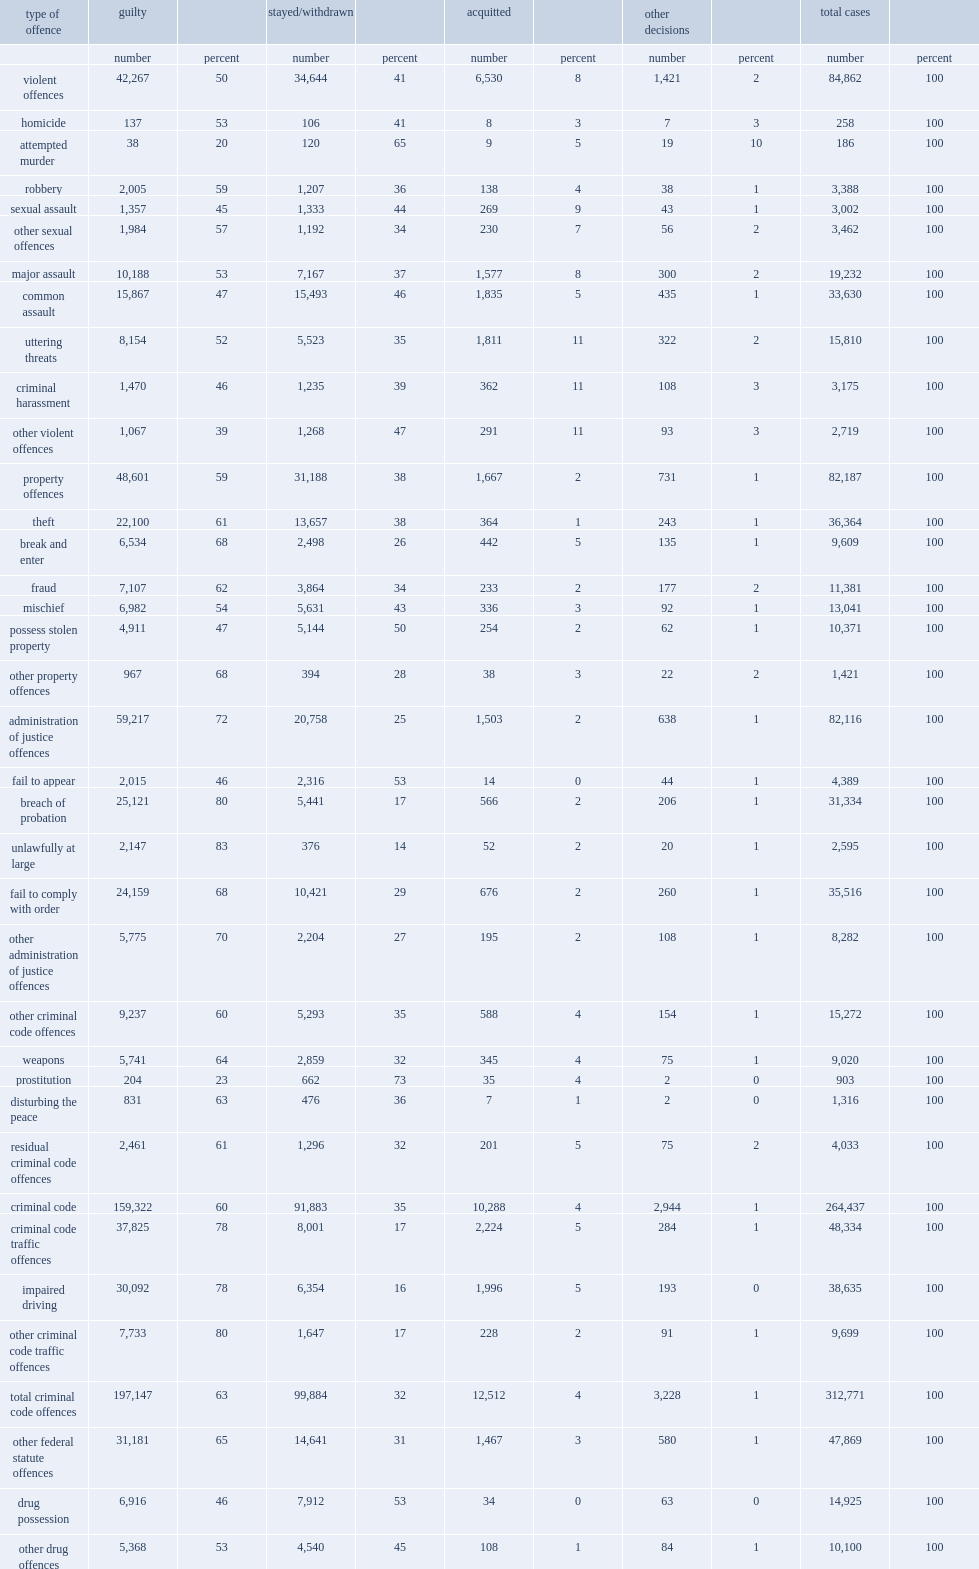In 2013/2014, what percentage of all cases completed in adult criminal court resulted in a finding of guilt? 63.0. In 2013/2014, what percentage of all cases completed in adult criminal court resulted in stayed or withdrawn? 32.0. In 2013/2014, what percentage of all cases completed in adult criminal court resulted in acquitted? 4.0. In 2013/2014, what percentage of all cases completed in adult criminal court resulted in another type of decision? 1.0. In 2013 / 2014, what percentage of cases involving violent crimes completed by adult criminal courts were convicted? 50.0. In 2013 / 2014, what percentage of cases involving property crimes completed by adult criminal courts were convicted? 59.0. In 2013 / 2014, what percentage of cases involvingadministration of justice offences completed by adult criminal courts were convicted? 72.0. In 2013/2014, what percentage of violent crimes were found guilty of robbery? 59.0. In 2013/2014, what percentage of violent crimes were found guilty of attempted murder cases? 20.0. What percentage of attempted murder cases are stayed/withdrawn? 65.0. What percentage of guilt cases fail to appear in court? 46.0. What percentage of guilt cases were unlawfully at large? 83.0. 